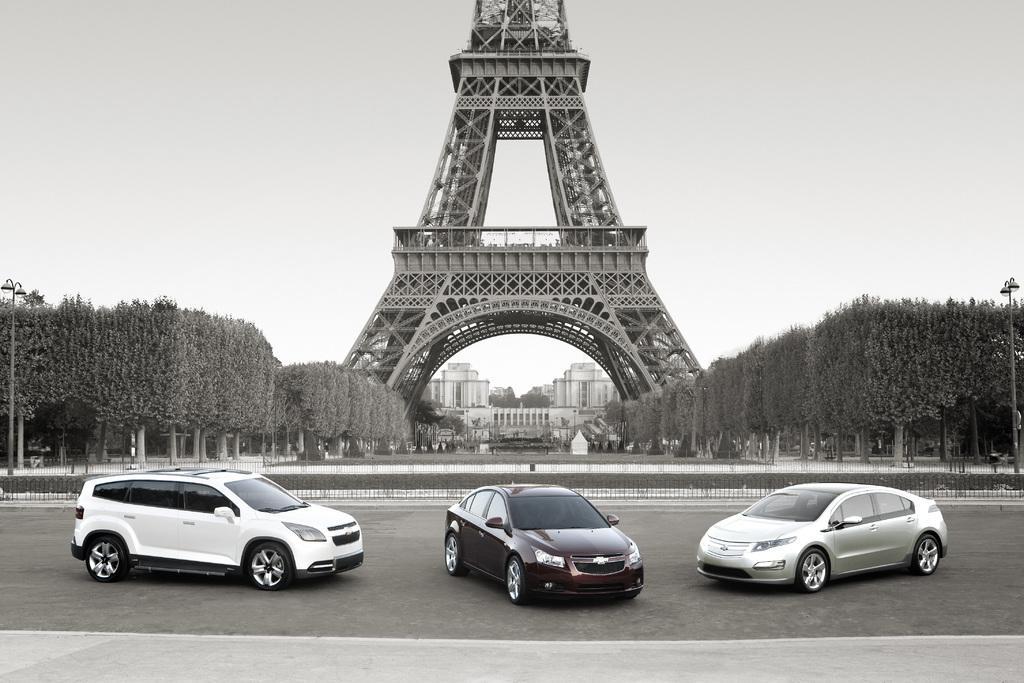How would you summarize this image in a sentence or two? In this image in the center there is an Eiffel tower and on the right side and left side there are some plants, in the foreground there are some plants. At the bottom there is road and in the background there are some buildings and trees and some other objects. On the right side and left side there are two poles. 